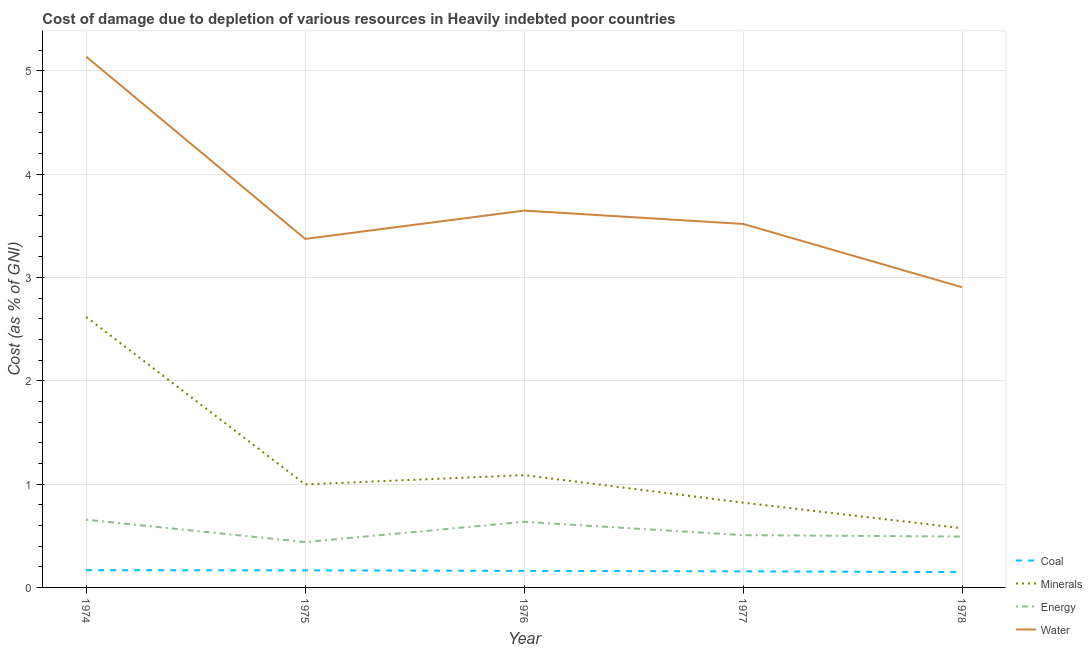How many different coloured lines are there?
Offer a terse response. 4. Does the line corresponding to cost of damage due to depletion of coal intersect with the line corresponding to cost of damage due to depletion of minerals?
Make the answer very short. No. Is the number of lines equal to the number of legend labels?
Keep it short and to the point. Yes. What is the cost of damage due to depletion of minerals in 1974?
Offer a very short reply. 2.62. Across all years, what is the maximum cost of damage due to depletion of water?
Your answer should be compact. 5.14. Across all years, what is the minimum cost of damage due to depletion of coal?
Ensure brevity in your answer.  0.15. In which year was the cost of damage due to depletion of energy maximum?
Offer a terse response. 1974. In which year was the cost of damage due to depletion of coal minimum?
Provide a short and direct response. 1978. What is the total cost of damage due to depletion of energy in the graph?
Give a very brief answer. 2.73. What is the difference between the cost of damage due to depletion of energy in 1977 and that in 1978?
Provide a short and direct response. 0.01. What is the difference between the cost of damage due to depletion of water in 1975 and the cost of damage due to depletion of energy in 1974?
Your answer should be very brief. 2.72. What is the average cost of damage due to depletion of minerals per year?
Your response must be concise. 1.22. In the year 1977, what is the difference between the cost of damage due to depletion of minerals and cost of damage due to depletion of coal?
Provide a short and direct response. 0.66. What is the ratio of the cost of damage due to depletion of coal in 1976 to that in 1978?
Keep it short and to the point. 1.08. Is the difference between the cost of damage due to depletion of minerals in 1974 and 1975 greater than the difference between the cost of damage due to depletion of energy in 1974 and 1975?
Keep it short and to the point. Yes. What is the difference between the highest and the second highest cost of damage due to depletion of coal?
Make the answer very short. 0. What is the difference between the highest and the lowest cost of damage due to depletion of coal?
Ensure brevity in your answer.  0.02. Is it the case that in every year, the sum of the cost of damage due to depletion of coal and cost of damage due to depletion of minerals is greater than the cost of damage due to depletion of energy?
Keep it short and to the point. Yes. Does the cost of damage due to depletion of minerals monotonically increase over the years?
Provide a succinct answer. No. How many years are there in the graph?
Give a very brief answer. 5. Does the graph contain any zero values?
Keep it short and to the point. No. How are the legend labels stacked?
Your answer should be compact. Vertical. What is the title of the graph?
Ensure brevity in your answer.  Cost of damage due to depletion of various resources in Heavily indebted poor countries . What is the label or title of the X-axis?
Your response must be concise. Year. What is the label or title of the Y-axis?
Provide a short and direct response. Cost (as % of GNI). What is the Cost (as % of GNI) in Coal in 1974?
Make the answer very short. 0.17. What is the Cost (as % of GNI) in Minerals in 1974?
Make the answer very short. 2.62. What is the Cost (as % of GNI) of Energy in 1974?
Your answer should be very brief. 0.66. What is the Cost (as % of GNI) in Water in 1974?
Give a very brief answer. 5.14. What is the Cost (as % of GNI) in Coal in 1975?
Provide a succinct answer. 0.17. What is the Cost (as % of GNI) of Minerals in 1975?
Your answer should be very brief. 1. What is the Cost (as % of GNI) of Energy in 1975?
Make the answer very short. 0.44. What is the Cost (as % of GNI) of Water in 1975?
Give a very brief answer. 3.37. What is the Cost (as % of GNI) of Coal in 1976?
Your answer should be very brief. 0.16. What is the Cost (as % of GNI) in Minerals in 1976?
Make the answer very short. 1.09. What is the Cost (as % of GNI) of Energy in 1976?
Offer a very short reply. 0.63. What is the Cost (as % of GNI) of Water in 1976?
Your answer should be very brief. 3.65. What is the Cost (as % of GNI) of Coal in 1977?
Give a very brief answer. 0.16. What is the Cost (as % of GNI) of Minerals in 1977?
Ensure brevity in your answer.  0.82. What is the Cost (as % of GNI) in Energy in 1977?
Your response must be concise. 0.51. What is the Cost (as % of GNI) in Water in 1977?
Provide a short and direct response. 3.52. What is the Cost (as % of GNI) of Coal in 1978?
Give a very brief answer. 0.15. What is the Cost (as % of GNI) of Minerals in 1978?
Ensure brevity in your answer.  0.57. What is the Cost (as % of GNI) of Energy in 1978?
Your response must be concise. 0.49. What is the Cost (as % of GNI) in Water in 1978?
Your answer should be compact. 2.9. Across all years, what is the maximum Cost (as % of GNI) in Coal?
Keep it short and to the point. 0.17. Across all years, what is the maximum Cost (as % of GNI) in Minerals?
Provide a short and direct response. 2.62. Across all years, what is the maximum Cost (as % of GNI) of Energy?
Your response must be concise. 0.66. Across all years, what is the maximum Cost (as % of GNI) in Water?
Offer a terse response. 5.14. Across all years, what is the minimum Cost (as % of GNI) in Coal?
Keep it short and to the point. 0.15. Across all years, what is the minimum Cost (as % of GNI) of Minerals?
Make the answer very short. 0.57. Across all years, what is the minimum Cost (as % of GNI) in Energy?
Provide a short and direct response. 0.44. Across all years, what is the minimum Cost (as % of GNI) in Water?
Keep it short and to the point. 2.9. What is the total Cost (as % of GNI) of Coal in the graph?
Your answer should be compact. 0.8. What is the total Cost (as % of GNI) of Minerals in the graph?
Provide a succinct answer. 6.1. What is the total Cost (as % of GNI) of Energy in the graph?
Your answer should be compact. 2.73. What is the total Cost (as % of GNI) in Water in the graph?
Make the answer very short. 18.58. What is the difference between the Cost (as % of GNI) of Coal in 1974 and that in 1975?
Your answer should be compact. 0. What is the difference between the Cost (as % of GNI) of Minerals in 1974 and that in 1975?
Provide a succinct answer. 1.62. What is the difference between the Cost (as % of GNI) of Energy in 1974 and that in 1975?
Your answer should be compact. 0.22. What is the difference between the Cost (as % of GNI) of Water in 1974 and that in 1975?
Keep it short and to the point. 1.76. What is the difference between the Cost (as % of GNI) of Coal in 1974 and that in 1976?
Give a very brief answer. 0.01. What is the difference between the Cost (as % of GNI) in Minerals in 1974 and that in 1976?
Provide a succinct answer. 1.53. What is the difference between the Cost (as % of GNI) in Energy in 1974 and that in 1976?
Offer a terse response. 0.02. What is the difference between the Cost (as % of GNI) of Water in 1974 and that in 1976?
Your response must be concise. 1.49. What is the difference between the Cost (as % of GNI) in Coal in 1974 and that in 1977?
Ensure brevity in your answer.  0.01. What is the difference between the Cost (as % of GNI) in Minerals in 1974 and that in 1977?
Provide a short and direct response. 1.8. What is the difference between the Cost (as % of GNI) of Energy in 1974 and that in 1977?
Your response must be concise. 0.15. What is the difference between the Cost (as % of GNI) in Water in 1974 and that in 1977?
Provide a succinct answer. 1.62. What is the difference between the Cost (as % of GNI) of Coal in 1974 and that in 1978?
Offer a terse response. 0.02. What is the difference between the Cost (as % of GNI) in Minerals in 1974 and that in 1978?
Give a very brief answer. 2.04. What is the difference between the Cost (as % of GNI) of Energy in 1974 and that in 1978?
Ensure brevity in your answer.  0.16. What is the difference between the Cost (as % of GNI) in Water in 1974 and that in 1978?
Keep it short and to the point. 2.23. What is the difference between the Cost (as % of GNI) of Coal in 1975 and that in 1976?
Offer a very short reply. 0.01. What is the difference between the Cost (as % of GNI) in Minerals in 1975 and that in 1976?
Provide a succinct answer. -0.09. What is the difference between the Cost (as % of GNI) in Energy in 1975 and that in 1976?
Give a very brief answer. -0.2. What is the difference between the Cost (as % of GNI) in Water in 1975 and that in 1976?
Make the answer very short. -0.27. What is the difference between the Cost (as % of GNI) in Coal in 1975 and that in 1977?
Your answer should be very brief. 0.01. What is the difference between the Cost (as % of GNI) of Minerals in 1975 and that in 1977?
Give a very brief answer. 0.18. What is the difference between the Cost (as % of GNI) in Energy in 1975 and that in 1977?
Provide a short and direct response. -0.07. What is the difference between the Cost (as % of GNI) of Water in 1975 and that in 1977?
Keep it short and to the point. -0.14. What is the difference between the Cost (as % of GNI) of Coal in 1975 and that in 1978?
Provide a short and direct response. 0.02. What is the difference between the Cost (as % of GNI) of Minerals in 1975 and that in 1978?
Offer a terse response. 0.42. What is the difference between the Cost (as % of GNI) in Energy in 1975 and that in 1978?
Give a very brief answer. -0.05. What is the difference between the Cost (as % of GNI) in Water in 1975 and that in 1978?
Offer a very short reply. 0.47. What is the difference between the Cost (as % of GNI) of Coal in 1976 and that in 1977?
Give a very brief answer. 0. What is the difference between the Cost (as % of GNI) in Minerals in 1976 and that in 1977?
Provide a short and direct response. 0.27. What is the difference between the Cost (as % of GNI) of Energy in 1976 and that in 1977?
Your answer should be compact. 0.13. What is the difference between the Cost (as % of GNI) in Water in 1976 and that in 1977?
Your response must be concise. 0.13. What is the difference between the Cost (as % of GNI) of Coal in 1976 and that in 1978?
Offer a terse response. 0.01. What is the difference between the Cost (as % of GNI) in Minerals in 1976 and that in 1978?
Your answer should be compact. 0.51. What is the difference between the Cost (as % of GNI) in Energy in 1976 and that in 1978?
Make the answer very short. 0.14. What is the difference between the Cost (as % of GNI) of Water in 1976 and that in 1978?
Your response must be concise. 0.74. What is the difference between the Cost (as % of GNI) in Coal in 1977 and that in 1978?
Give a very brief answer. 0.01. What is the difference between the Cost (as % of GNI) of Minerals in 1977 and that in 1978?
Your response must be concise. 0.25. What is the difference between the Cost (as % of GNI) of Energy in 1977 and that in 1978?
Your answer should be compact. 0.01. What is the difference between the Cost (as % of GNI) of Water in 1977 and that in 1978?
Provide a succinct answer. 0.61. What is the difference between the Cost (as % of GNI) of Coal in 1974 and the Cost (as % of GNI) of Minerals in 1975?
Provide a short and direct response. -0.83. What is the difference between the Cost (as % of GNI) in Coal in 1974 and the Cost (as % of GNI) in Energy in 1975?
Provide a short and direct response. -0.27. What is the difference between the Cost (as % of GNI) in Coal in 1974 and the Cost (as % of GNI) in Water in 1975?
Offer a very short reply. -3.21. What is the difference between the Cost (as % of GNI) of Minerals in 1974 and the Cost (as % of GNI) of Energy in 1975?
Your answer should be very brief. 2.18. What is the difference between the Cost (as % of GNI) of Minerals in 1974 and the Cost (as % of GNI) of Water in 1975?
Keep it short and to the point. -0.76. What is the difference between the Cost (as % of GNI) in Energy in 1974 and the Cost (as % of GNI) in Water in 1975?
Provide a short and direct response. -2.72. What is the difference between the Cost (as % of GNI) of Coal in 1974 and the Cost (as % of GNI) of Minerals in 1976?
Provide a short and direct response. -0.92. What is the difference between the Cost (as % of GNI) in Coal in 1974 and the Cost (as % of GNI) in Energy in 1976?
Keep it short and to the point. -0.47. What is the difference between the Cost (as % of GNI) in Coal in 1974 and the Cost (as % of GNI) in Water in 1976?
Give a very brief answer. -3.48. What is the difference between the Cost (as % of GNI) in Minerals in 1974 and the Cost (as % of GNI) in Energy in 1976?
Your answer should be compact. 1.98. What is the difference between the Cost (as % of GNI) in Minerals in 1974 and the Cost (as % of GNI) in Water in 1976?
Make the answer very short. -1.03. What is the difference between the Cost (as % of GNI) of Energy in 1974 and the Cost (as % of GNI) of Water in 1976?
Offer a very short reply. -2.99. What is the difference between the Cost (as % of GNI) in Coal in 1974 and the Cost (as % of GNI) in Minerals in 1977?
Your response must be concise. -0.65. What is the difference between the Cost (as % of GNI) in Coal in 1974 and the Cost (as % of GNI) in Energy in 1977?
Your answer should be compact. -0.34. What is the difference between the Cost (as % of GNI) of Coal in 1974 and the Cost (as % of GNI) of Water in 1977?
Offer a terse response. -3.35. What is the difference between the Cost (as % of GNI) in Minerals in 1974 and the Cost (as % of GNI) in Energy in 1977?
Give a very brief answer. 2.11. What is the difference between the Cost (as % of GNI) in Minerals in 1974 and the Cost (as % of GNI) in Water in 1977?
Offer a very short reply. -0.9. What is the difference between the Cost (as % of GNI) in Energy in 1974 and the Cost (as % of GNI) in Water in 1977?
Offer a terse response. -2.86. What is the difference between the Cost (as % of GNI) in Coal in 1974 and the Cost (as % of GNI) in Minerals in 1978?
Make the answer very short. -0.41. What is the difference between the Cost (as % of GNI) in Coal in 1974 and the Cost (as % of GNI) in Energy in 1978?
Offer a terse response. -0.33. What is the difference between the Cost (as % of GNI) in Coal in 1974 and the Cost (as % of GNI) in Water in 1978?
Give a very brief answer. -2.74. What is the difference between the Cost (as % of GNI) in Minerals in 1974 and the Cost (as % of GNI) in Energy in 1978?
Your response must be concise. 2.13. What is the difference between the Cost (as % of GNI) in Minerals in 1974 and the Cost (as % of GNI) in Water in 1978?
Offer a very short reply. -0.29. What is the difference between the Cost (as % of GNI) of Energy in 1974 and the Cost (as % of GNI) of Water in 1978?
Ensure brevity in your answer.  -2.25. What is the difference between the Cost (as % of GNI) of Coal in 1975 and the Cost (as % of GNI) of Minerals in 1976?
Offer a very short reply. -0.92. What is the difference between the Cost (as % of GNI) of Coal in 1975 and the Cost (as % of GNI) of Energy in 1976?
Provide a short and direct response. -0.47. What is the difference between the Cost (as % of GNI) of Coal in 1975 and the Cost (as % of GNI) of Water in 1976?
Make the answer very short. -3.48. What is the difference between the Cost (as % of GNI) in Minerals in 1975 and the Cost (as % of GNI) in Energy in 1976?
Your response must be concise. 0.36. What is the difference between the Cost (as % of GNI) of Minerals in 1975 and the Cost (as % of GNI) of Water in 1976?
Your response must be concise. -2.65. What is the difference between the Cost (as % of GNI) of Energy in 1975 and the Cost (as % of GNI) of Water in 1976?
Ensure brevity in your answer.  -3.21. What is the difference between the Cost (as % of GNI) of Coal in 1975 and the Cost (as % of GNI) of Minerals in 1977?
Give a very brief answer. -0.66. What is the difference between the Cost (as % of GNI) of Coal in 1975 and the Cost (as % of GNI) of Energy in 1977?
Your answer should be compact. -0.34. What is the difference between the Cost (as % of GNI) in Coal in 1975 and the Cost (as % of GNI) in Water in 1977?
Offer a terse response. -3.35. What is the difference between the Cost (as % of GNI) of Minerals in 1975 and the Cost (as % of GNI) of Energy in 1977?
Offer a terse response. 0.49. What is the difference between the Cost (as % of GNI) in Minerals in 1975 and the Cost (as % of GNI) in Water in 1977?
Your answer should be very brief. -2.52. What is the difference between the Cost (as % of GNI) in Energy in 1975 and the Cost (as % of GNI) in Water in 1977?
Your response must be concise. -3.08. What is the difference between the Cost (as % of GNI) of Coal in 1975 and the Cost (as % of GNI) of Minerals in 1978?
Provide a succinct answer. -0.41. What is the difference between the Cost (as % of GNI) in Coal in 1975 and the Cost (as % of GNI) in Energy in 1978?
Give a very brief answer. -0.33. What is the difference between the Cost (as % of GNI) in Coal in 1975 and the Cost (as % of GNI) in Water in 1978?
Provide a short and direct response. -2.74. What is the difference between the Cost (as % of GNI) of Minerals in 1975 and the Cost (as % of GNI) of Energy in 1978?
Make the answer very short. 0.5. What is the difference between the Cost (as % of GNI) of Minerals in 1975 and the Cost (as % of GNI) of Water in 1978?
Ensure brevity in your answer.  -1.91. What is the difference between the Cost (as % of GNI) of Energy in 1975 and the Cost (as % of GNI) of Water in 1978?
Provide a succinct answer. -2.47. What is the difference between the Cost (as % of GNI) in Coal in 1976 and the Cost (as % of GNI) in Minerals in 1977?
Give a very brief answer. -0.66. What is the difference between the Cost (as % of GNI) of Coal in 1976 and the Cost (as % of GNI) of Energy in 1977?
Provide a succinct answer. -0.35. What is the difference between the Cost (as % of GNI) in Coal in 1976 and the Cost (as % of GNI) in Water in 1977?
Ensure brevity in your answer.  -3.36. What is the difference between the Cost (as % of GNI) in Minerals in 1976 and the Cost (as % of GNI) in Energy in 1977?
Your response must be concise. 0.58. What is the difference between the Cost (as % of GNI) in Minerals in 1976 and the Cost (as % of GNI) in Water in 1977?
Offer a terse response. -2.43. What is the difference between the Cost (as % of GNI) of Energy in 1976 and the Cost (as % of GNI) of Water in 1977?
Ensure brevity in your answer.  -2.88. What is the difference between the Cost (as % of GNI) of Coal in 1976 and the Cost (as % of GNI) of Minerals in 1978?
Your answer should be compact. -0.41. What is the difference between the Cost (as % of GNI) in Coal in 1976 and the Cost (as % of GNI) in Energy in 1978?
Provide a short and direct response. -0.33. What is the difference between the Cost (as % of GNI) of Coal in 1976 and the Cost (as % of GNI) of Water in 1978?
Your answer should be very brief. -2.74. What is the difference between the Cost (as % of GNI) of Minerals in 1976 and the Cost (as % of GNI) of Energy in 1978?
Your answer should be compact. 0.59. What is the difference between the Cost (as % of GNI) of Minerals in 1976 and the Cost (as % of GNI) of Water in 1978?
Offer a very short reply. -1.82. What is the difference between the Cost (as % of GNI) in Energy in 1976 and the Cost (as % of GNI) in Water in 1978?
Your answer should be compact. -2.27. What is the difference between the Cost (as % of GNI) in Coal in 1977 and the Cost (as % of GNI) in Minerals in 1978?
Your response must be concise. -0.42. What is the difference between the Cost (as % of GNI) of Coal in 1977 and the Cost (as % of GNI) of Energy in 1978?
Ensure brevity in your answer.  -0.34. What is the difference between the Cost (as % of GNI) of Coal in 1977 and the Cost (as % of GNI) of Water in 1978?
Your answer should be compact. -2.75. What is the difference between the Cost (as % of GNI) in Minerals in 1977 and the Cost (as % of GNI) in Energy in 1978?
Offer a very short reply. 0.33. What is the difference between the Cost (as % of GNI) in Minerals in 1977 and the Cost (as % of GNI) in Water in 1978?
Offer a very short reply. -2.08. What is the difference between the Cost (as % of GNI) in Energy in 1977 and the Cost (as % of GNI) in Water in 1978?
Keep it short and to the point. -2.4. What is the average Cost (as % of GNI) in Coal per year?
Give a very brief answer. 0.16. What is the average Cost (as % of GNI) in Minerals per year?
Offer a very short reply. 1.22. What is the average Cost (as % of GNI) in Energy per year?
Ensure brevity in your answer.  0.55. What is the average Cost (as % of GNI) of Water per year?
Offer a very short reply. 3.72. In the year 1974, what is the difference between the Cost (as % of GNI) of Coal and Cost (as % of GNI) of Minerals?
Give a very brief answer. -2.45. In the year 1974, what is the difference between the Cost (as % of GNI) in Coal and Cost (as % of GNI) in Energy?
Your answer should be very brief. -0.49. In the year 1974, what is the difference between the Cost (as % of GNI) of Coal and Cost (as % of GNI) of Water?
Keep it short and to the point. -4.97. In the year 1974, what is the difference between the Cost (as % of GNI) in Minerals and Cost (as % of GNI) in Energy?
Keep it short and to the point. 1.96. In the year 1974, what is the difference between the Cost (as % of GNI) of Minerals and Cost (as % of GNI) of Water?
Give a very brief answer. -2.52. In the year 1974, what is the difference between the Cost (as % of GNI) of Energy and Cost (as % of GNI) of Water?
Your response must be concise. -4.48. In the year 1975, what is the difference between the Cost (as % of GNI) in Coal and Cost (as % of GNI) in Minerals?
Your answer should be compact. -0.83. In the year 1975, what is the difference between the Cost (as % of GNI) in Coal and Cost (as % of GNI) in Energy?
Your answer should be compact. -0.27. In the year 1975, what is the difference between the Cost (as % of GNI) of Coal and Cost (as % of GNI) of Water?
Offer a terse response. -3.21. In the year 1975, what is the difference between the Cost (as % of GNI) of Minerals and Cost (as % of GNI) of Energy?
Make the answer very short. 0.56. In the year 1975, what is the difference between the Cost (as % of GNI) of Minerals and Cost (as % of GNI) of Water?
Your response must be concise. -2.38. In the year 1975, what is the difference between the Cost (as % of GNI) in Energy and Cost (as % of GNI) in Water?
Provide a succinct answer. -2.93. In the year 1976, what is the difference between the Cost (as % of GNI) of Coal and Cost (as % of GNI) of Minerals?
Provide a short and direct response. -0.93. In the year 1976, what is the difference between the Cost (as % of GNI) of Coal and Cost (as % of GNI) of Energy?
Provide a succinct answer. -0.47. In the year 1976, what is the difference between the Cost (as % of GNI) of Coal and Cost (as % of GNI) of Water?
Your response must be concise. -3.49. In the year 1976, what is the difference between the Cost (as % of GNI) in Minerals and Cost (as % of GNI) in Energy?
Offer a very short reply. 0.45. In the year 1976, what is the difference between the Cost (as % of GNI) in Minerals and Cost (as % of GNI) in Water?
Ensure brevity in your answer.  -2.56. In the year 1976, what is the difference between the Cost (as % of GNI) in Energy and Cost (as % of GNI) in Water?
Your response must be concise. -3.01. In the year 1977, what is the difference between the Cost (as % of GNI) of Coal and Cost (as % of GNI) of Minerals?
Your answer should be very brief. -0.66. In the year 1977, what is the difference between the Cost (as % of GNI) of Coal and Cost (as % of GNI) of Energy?
Provide a succinct answer. -0.35. In the year 1977, what is the difference between the Cost (as % of GNI) in Coal and Cost (as % of GNI) in Water?
Ensure brevity in your answer.  -3.36. In the year 1977, what is the difference between the Cost (as % of GNI) of Minerals and Cost (as % of GNI) of Energy?
Offer a terse response. 0.31. In the year 1977, what is the difference between the Cost (as % of GNI) in Minerals and Cost (as % of GNI) in Water?
Ensure brevity in your answer.  -2.7. In the year 1977, what is the difference between the Cost (as % of GNI) of Energy and Cost (as % of GNI) of Water?
Provide a short and direct response. -3.01. In the year 1978, what is the difference between the Cost (as % of GNI) in Coal and Cost (as % of GNI) in Minerals?
Give a very brief answer. -0.42. In the year 1978, what is the difference between the Cost (as % of GNI) in Coal and Cost (as % of GNI) in Energy?
Your answer should be very brief. -0.34. In the year 1978, what is the difference between the Cost (as % of GNI) of Coal and Cost (as % of GNI) of Water?
Give a very brief answer. -2.76. In the year 1978, what is the difference between the Cost (as % of GNI) in Minerals and Cost (as % of GNI) in Energy?
Offer a very short reply. 0.08. In the year 1978, what is the difference between the Cost (as % of GNI) in Minerals and Cost (as % of GNI) in Water?
Keep it short and to the point. -2.33. In the year 1978, what is the difference between the Cost (as % of GNI) of Energy and Cost (as % of GNI) of Water?
Keep it short and to the point. -2.41. What is the ratio of the Cost (as % of GNI) in Coal in 1974 to that in 1975?
Your answer should be compact. 1.01. What is the ratio of the Cost (as % of GNI) of Minerals in 1974 to that in 1975?
Ensure brevity in your answer.  2.63. What is the ratio of the Cost (as % of GNI) in Energy in 1974 to that in 1975?
Give a very brief answer. 1.49. What is the ratio of the Cost (as % of GNI) in Water in 1974 to that in 1975?
Give a very brief answer. 1.52. What is the ratio of the Cost (as % of GNI) of Coal in 1974 to that in 1976?
Offer a terse response. 1.04. What is the ratio of the Cost (as % of GNI) in Minerals in 1974 to that in 1976?
Provide a short and direct response. 2.41. What is the ratio of the Cost (as % of GNI) of Energy in 1974 to that in 1976?
Your answer should be compact. 1.03. What is the ratio of the Cost (as % of GNI) of Water in 1974 to that in 1976?
Make the answer very short. 1.41. What is the ratio of the Cost (as % of GNI) of Coal in 1974 to that in 1977?
Ensure brevity in your answer.  1.07. What is the ratio of the Cost (as % of GNI) of Minerals in 1974 to that in 1977?
Give a very brief answer. 3.19. What is the ratio of the Cost (as % of GNI) of Energy in 1974 to that in 1977?
Your answer should be very brief. 1.29. What is the ratio of the Cost (as % of GNI) of Water in 1974 to that in 1977?
Your response must be concise. 1.46. What is the ratio of the Cost (as % of GNI) of Coal in 1974 to that in 1978?
Your answer should be compact. 1.13. What is the ratio of the Cost (as % of GNI) in Minerals in 1974 to that in 1978?
Your answer should be compact. 4.57. What is the ratio of the Cost (as % of GNI) in Energy in 1974 to that in 1978?
Offer a very short reply. 1.33. What is the ratio of the Cost (as % of GNI) of Water in 1974 to that in 1978?
Your answer should be compact. 1.77. What is the ratio of the Cost (as % of GNI) in Coal in 1975 to that in 1976?
Provide a short and direct response. 1.03. What is the ratio of the Cost (as % of GNI) of Minerals in 1975 to that in 1976?
Provide a succinct answer. 0.92. What is the ratio of the Cost (as % of GNI) of Energy in 1975 to that in 1976?
Ensure brevity in your answer.  0.69. What is the ratio of the Cost (as % of GNI) in Water in 1975 to that in 1976?
Offer a terse response. 0.92. What is the ratio of the Cost (as % of GNI) of Coal in 1975 to that in 1977?
Your answer should be very brief. 1.06. What is the ratio of the Cost (as % of GNI) of Minerals in 1975 to that in 1977?
Your answer should be compact. 1.22. What is the ratio of the Cost (as % of GNI) in Energy in 1975 to that in 1977?
Provide a short and direct response. 0.87. What is the ratio of the Cost (as % of GNI) in Water in 1975 to that in 1977?
Your answer should be very brief. 0.96. What is the ratio of the Cost (as % of GNI) in Coal in 1975 to that in 1978?
Your answer should be very brief. 1.12. What is the ratio of the Cost (as % of GNI) in Minerals in 1975 to that in 1978?
Keep it short and to the point. 1.74. What is the ratio of the Cost (as % of GNI) of Energy in 1975 to that in 1978?
Your answer should be very brief. 0.89. What is the ratio of the Cost (as % of GNI) of Water in 1975 to that in 1978?
Your answer should be compact. 1.16. What is the ratio of the Cost (as % of GNI) in Coal in 1976 to that in 1977?
Make the answer very short. 1.03. What is the ratio of the Cost (as % of GNI) in Minerals in 1976 to that in 1977?
Offer a terse response. 1.32. What is the ratio of the Cost (as % of GNI) in Energy in 1976 to that in 1977?
Make the answer very short. 1.25. What is the ratio of the Cost (as % of GNI) in Water in 1976 to that in 1977?
Offer a very short reply. 1.04. What is the ratio of the Cost (as % of GNI) of Coal in 1976 to that in 1978?
Ensure brevity in your answer.  1.08. What is the ratio of the Cost (as % of GNI) in Minerals in 1976 to that in 1978?
Offer a terse response. 1.9. What is the ratio of the Cost (as % of GNI) of Energy in 1976 to that in 1978?
Your answer should be compact. 1.29. What is the ratio of the Cost (as % of GNI) of Water in 1976 to that in 1978?
Provide a succinct answer. 1.26. What is the ratio of the Cost (as % of GNI) of Coal in 1977 to that in 1978?
Your answer should be very brief. 1.05. What is the ratio of the Cost (as % of GNI) in Minerals in 1977 to that in 1978?
Keep it short and to the point. 1.43. What is the ratio of the Cost (as % of GNI) in Energy in 1977 to that in 1978?
Offer a terse response. 1.03. What is the ratio of the Cost (as % of GNI) of Water in 1977 to that in 1978?
Make the answer very short. 1.21. What is the difference between the highest and the second highest Cost (as % of GNI) in Coal?
Ensure brevity in your answer.  0. What is the difference between the highest and the second highest Cost (as % of GNI) in Minerals?
Your response must be concise. 1.53. What is the difference between the highest and the second highest Cost (as % of GNI) of Energy?
Offer a terse response. 0.02. What is the difference between the highest and the second highest Cost (as % of GNI) in Water?
Your answer should be compact. 1.49. What is the difference between the highest and the lowest Cost (as % of GNI) of Coal?
Offer a terse response. 0.02. What is the difference between the highest and the lowest Cost (as % of GNI) in Minerals?
Offer a terse response. 2.04. What is the difference between the highest and the lowest Cost (as % of GNI) in Energy?
Offer a very short reply. 0.22. What is the difference between the highest and the lowest Cost (as % of GNI) in Water?
Keep it short and to the point. 2.23. 